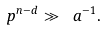Convert formula to latex. <formula><loc_0><loc_0><loc_500><loc_500>p ^ { n - d } \gg \ a ^ { - 1 } .</formula> 